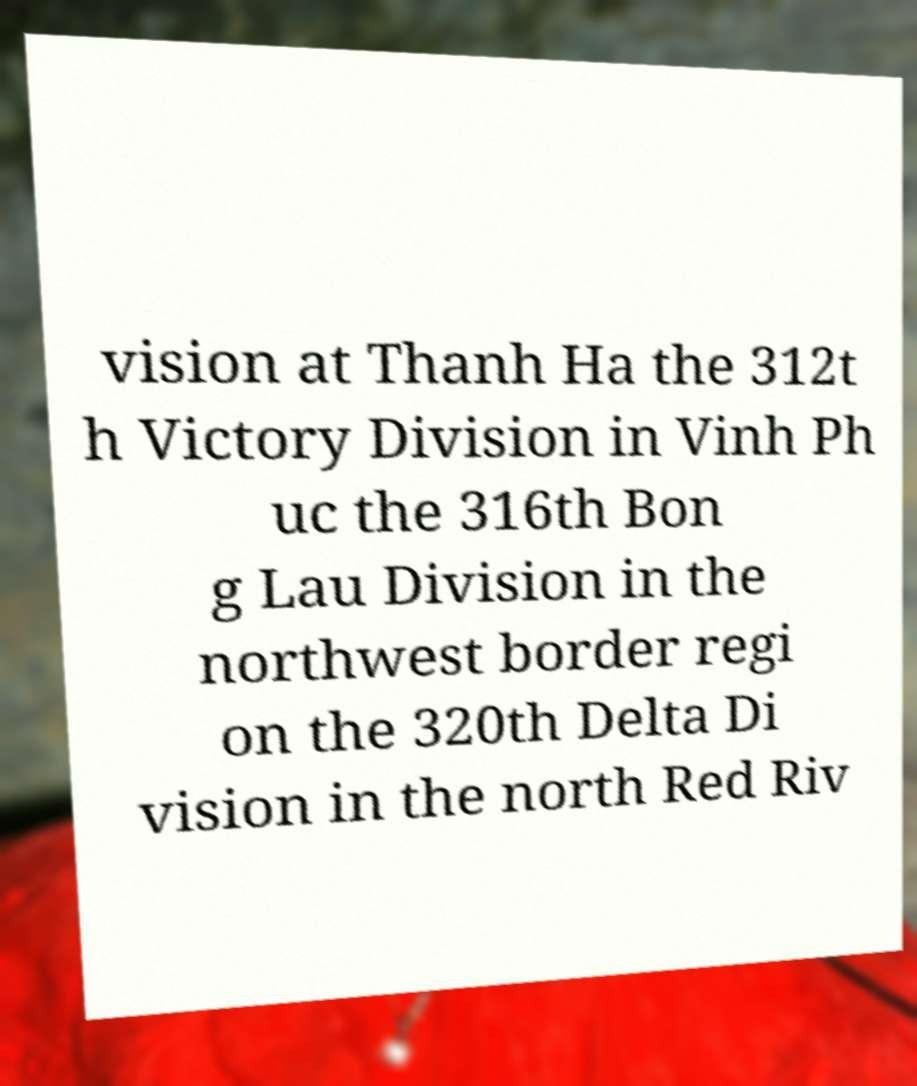For documentation purposes, I need the text within this image transcribed. Could you provide that? vision at Thanh Ha the 312t h Victory Division in Vinh Ph uc the 316th Bon g Lau Division in the northwest border regi on the 320th Delta Di vision in the north Red Riv 